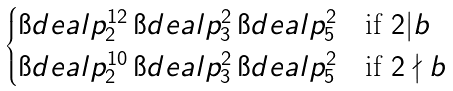Convert formula to latex. <formula><loc_0><loc_0><loc_500><loc_500>\begin{cases} \i d e a l { p } _ { 2 } ^ { 1 2 } \, \i d e a l { p } _ { 3 } ^ { 2 } \, \i d e a l { p } _ { 5 } ^ { 2 } & \text {if } 2 | b \\ \i d e a l { p } _ { 2 } ^ { 1 0 } \, \i d e a l { p } _ { 3 } ^ { 2 } \, \i d e a l { p } _ { 5 } ^ { 2 } & \text {if } 2 \nmid b \end{cases}</formula> 